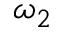<formula> <loc_0><loc_0><loc_500><loc_500>\omega _ { 2 }</formula> 